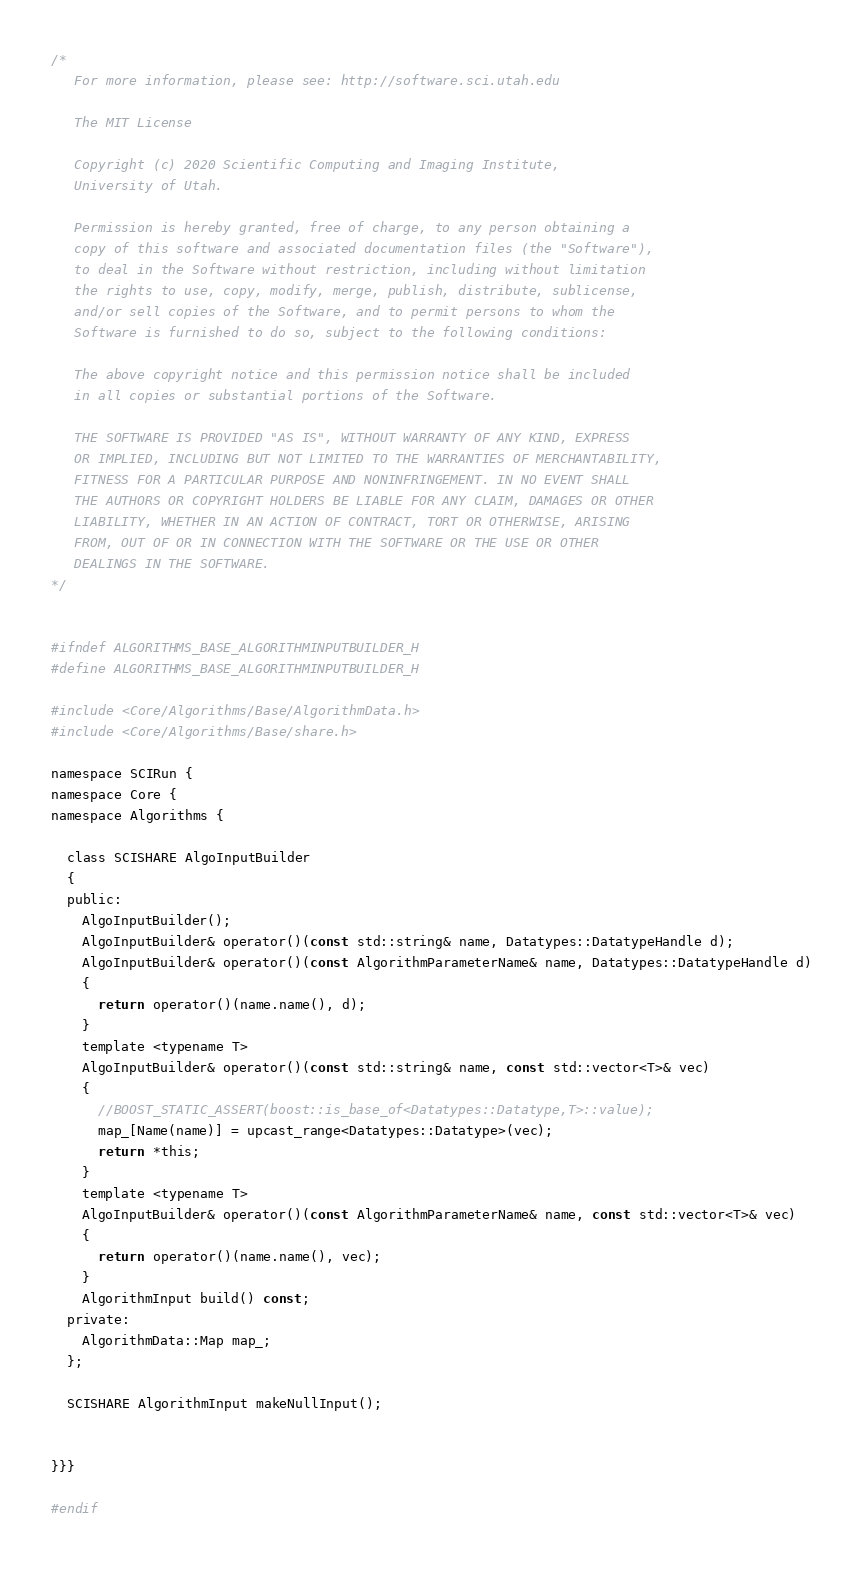Convert code to text. <code><loc_0><loc_0><loc_500><loc_500><_C_>/*
   For more information, please see: http://software.sci.utah.edu

   The MIT License

   Copyright (c) 2020 Scientific Computing and Imaging Institute,
   University of Utah.

   Permission is hereby granted, free of charge, to any person obtaining a
   copy of this software and associated documentation files (the "Software"),
   to deal in the Software without restriction, including without limitation
   the rights to use, copy, modify, merge, publish, distribute, sublicense,
   and/or sell copies of the Software, and to permit persons to whom the
   Software is furnished to do so, subject to the following conditions:

   The above copyright notice and this permission notice shall be included
   in all copies or substantial portions of the Software.

   THE SOFTWARE IS PROVIDED "AS IS", WITHOUT WARRANTY OF ANY KIND, EXPRESS
   OR IMPLIED, INCLUDING BUT NOT LIMITED TO THE WARRANTIES OF MERCHANTABILITY,
   FITNESS FOR A PARTICULAR PURPOSE AND NONINFRINGEMENT. IN NO EVENT SHALL
   THE AUTHORS OR COPYRIGHT HOLDERS BE LIABLE FOR ANY CLAIM, DAMAGES OR OTHER
   LIABILITY, WHETHER IN AN ACTION OF CONTRACT, TORT OR OTHERWISE, ARISING
   FROM, OUT OF OR IN CONNECTION WITH THE SOFTWARE OR THE USE OR OTHER
   DEALINGS IN THE SOFTWARE.
*/


#ifndef ALGORITHMS_BASE_ALGORITHMINPUTBUILDER_H
#define ALGORITHMS_BASE_ALGORITHMINPUTBUILDER_H

#include <Core/Algorithms/Base/AlgorithmData.h>
#include <Core/Algorithms/Base/share.h>

namespace SCIRun {
namespace Core {
namespace Algorithms {

  class SCISHARE AlgoInputBuilder
  {
  public:
    AlgoInputBuilder();
    AlgoInputBuilder& operator()(const std::string& name, Datatypes::DatatypeHandle d);
    AlgoInputBuilder& operator()(const AlgorithmParameterName& name, Datatypes::DatatypeHandle d)
    {
      return operator()(name.name(), d);
    }
    template <typename T>
    AlgoInputBuilder& operator()(const std::string& name, const std::vector<T>& vec)
    {
      //BOOST_STATIC_ASSERT(boost::is_base_of<Datatypes::Datatype,T>::value);
      map_[Name(name)] = upcast_range<Datatypes::Datatype>(vec);
      return *this;
    }
    template <typename T>
    AlgoInputBuilder& operator()(const AlgorithmParameterName& name, const std::vector<T>& vec)
    {
      return operator()(name.name(), vec);
    }
    AlgorithmInput build() const;
  private:
    AlgorithmData::Map map_;
  };

  SCISHARE AlgorithmInput makeNullInput();


}}}

#endif
</code> 